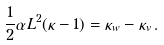Convert formula to latex. <formula><loc_0><loc_0><loc_500><loc_500>\frac { 1 } { 2 } \alpha L ^ { 2 } ( \kappa - 1 ) = \kappa _ { w } - \kappa _ { v } \, .</formula> 